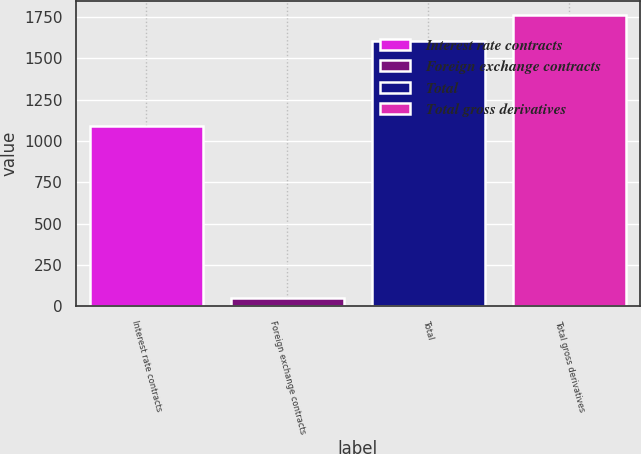Convert chart to OTSL. <chart><loc_0><loc_0><loc_500><loc_500><bar_chart><fcel>Interest rate contracts<fcel>Foreign exchange contracts<fcel>Total<fcel>Total gross derivatives<nl><fcel>1089<fcel>51<fcel>1606<fcel>1761.5<nl></chart> 